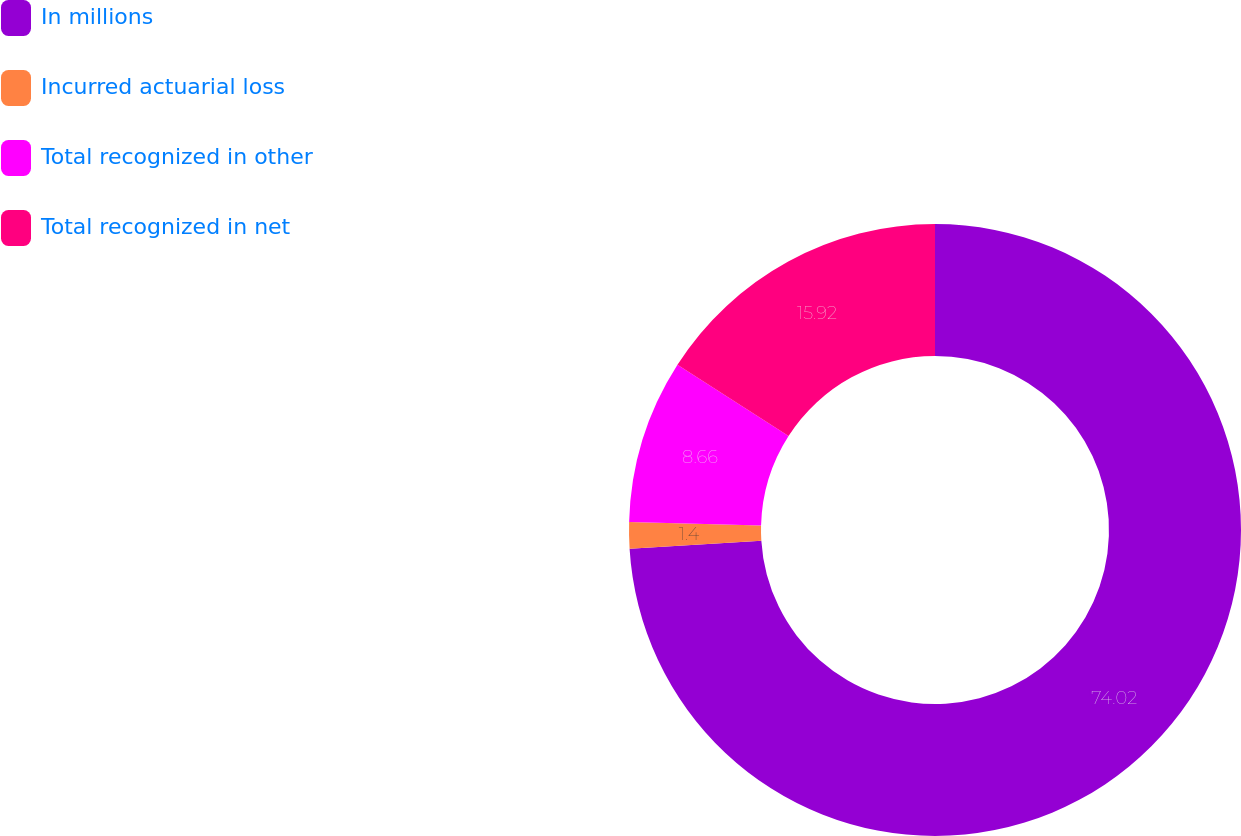Convert chart to OTSL. <chart><loc_0><loc_0><loc_500><loc_500><pie_chart><fcel>In millions<fcel>Incurred actuarial loss<fcel>Total recognized in other<fcel>Total recognized in net<nl><fcel>74.02%<fcel>1.4%<fcel>8.66%<fcel>15.92%<nl></chart> 